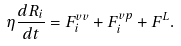<formula> <loc_0><loc_0><loc_500><loc_500>\eta \frac { d { R } _ { i } } { d t } = { F } ^ { v v } _ { i } + { F } ^ { v p } _ { i } + { F } ^ { L } .</formula> 